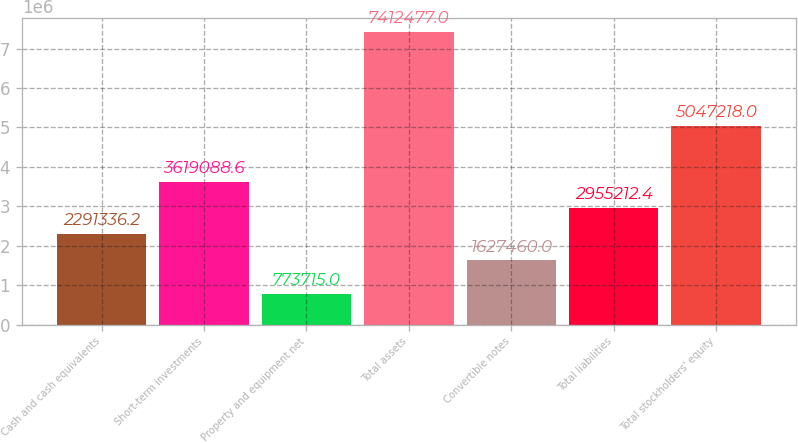Convert chart. <chart><loc_0><loc_0><loc_500><loc_500><bar_chart><fcel>Cash and cash equivalents<fcel>Short-term investments<fcel>Property and equipment net<fcel>Total assets<fcel>Convertible notes<fcel>Total liabilities<fcel>Total stockholders' equity<nl><fcel>2.29134e+06<fcel>3.61909e+06<fcel>773715<fcel>7.41248e+06<fcel>1.62746e+06<fcel>2.95521e+06<fcel>5.04722e+06<nl></chart> 